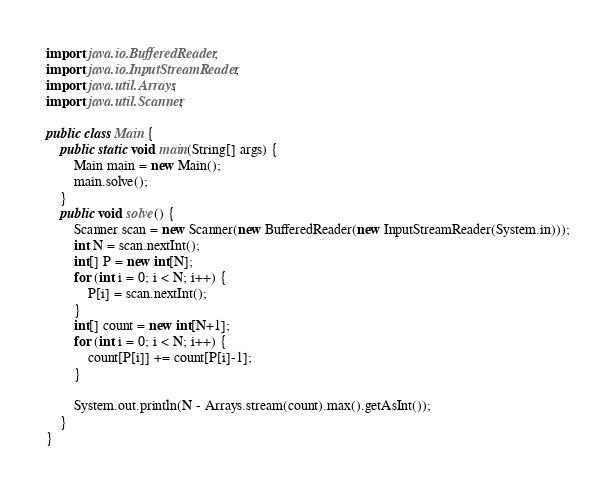Convert code to text. <code><loc_0><loc_0><loc_500><loc_500><_Java_>import java.io.BufferedReader;
import java.io.InputStreamReader;
import java.util.Arrays;
import java.util.Scanner;

public class Main {
    public static void main(String[] args) {
        Main main = new Main();
        main.solve();
    }
    public void solve() {
        Scanner scan = new Scanner(new BufferedReader(new InputStreamReader(System.in)));
        int N = scan.nextInt();
        int[] P = new int[N];
        for (int i = 0; i < N; i++) {
            P[i] = scan.nextInt();
        }
        int[] count = new int[N+1];
        for (int i = 0; i < N; i++) {
            count[P[i]] += count[P[i]-1];
        }

        System.out.println(N - Arrays.stream(count).max().getAsInt());
    }
}
</code> 